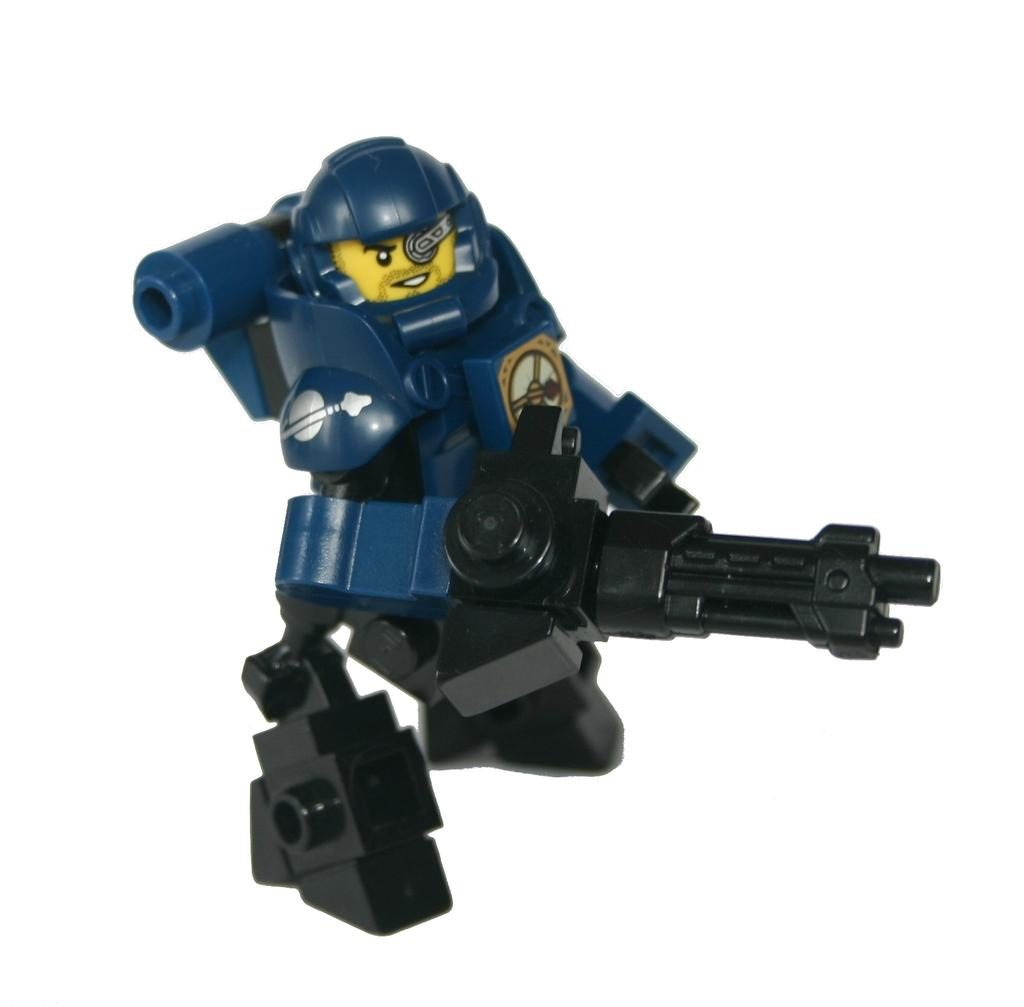What object can be seen in the image? There is a toy in the image. Where is the toy placed in the image? The toy is on a white surface. What color is the background of the image? The background of the image is white. What is the weight of the carpenter in the image? There is no carpenter present in the image, so it is not possible to determine their weight. 